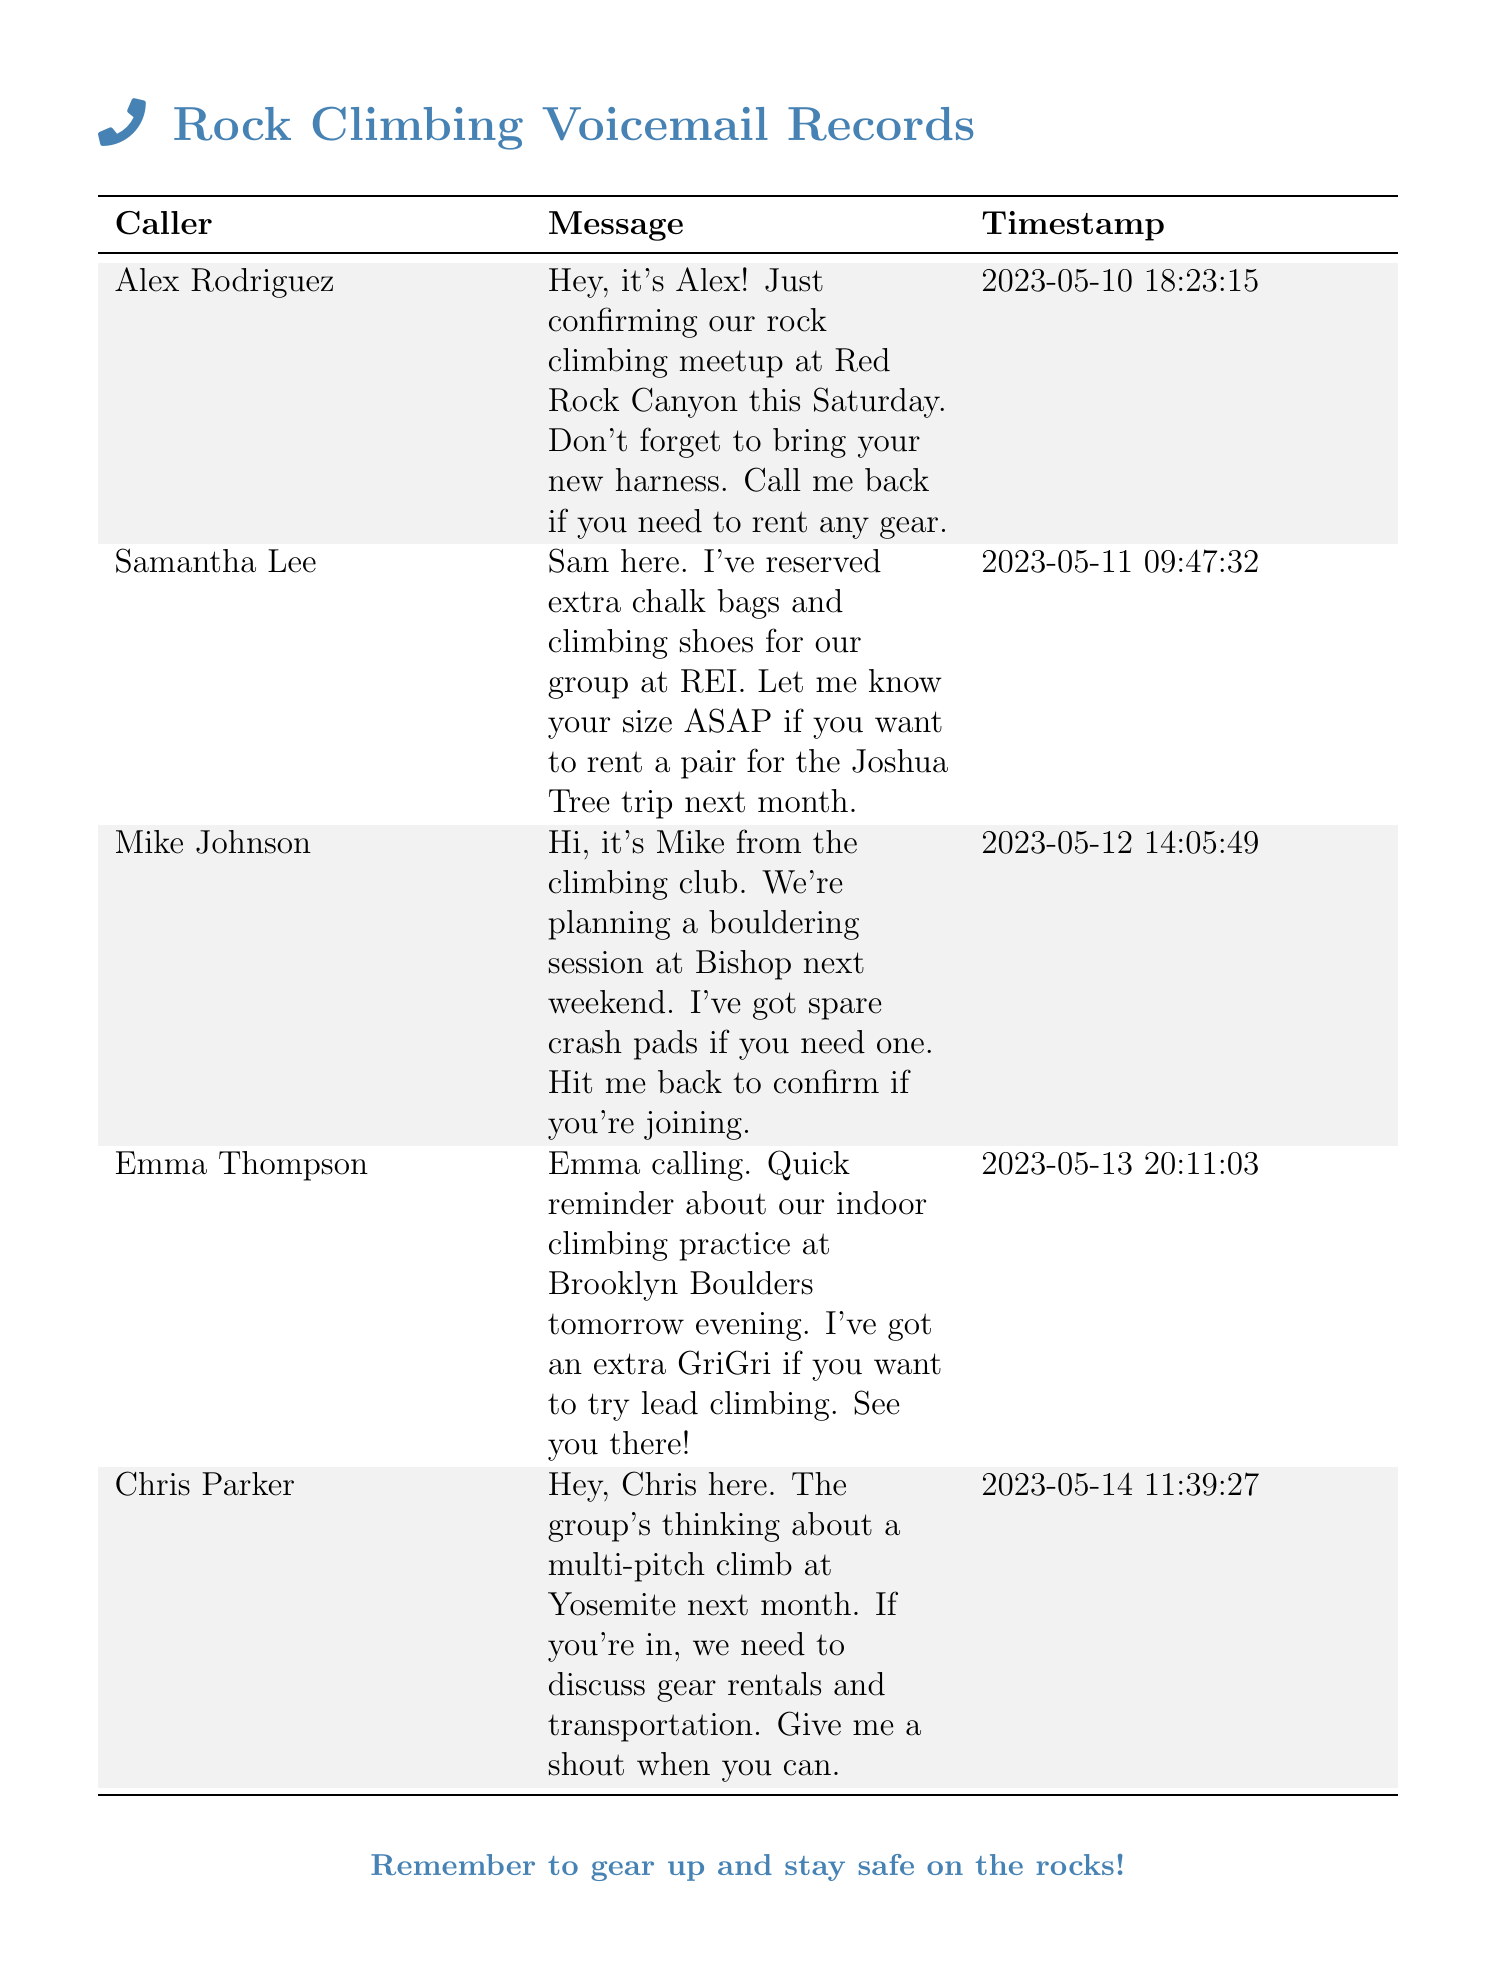What is the date of the rock climbing meetup at Red Rock Canyon? The date mentioned for the meetup at Red Rock Canyon is Saturday, May 13, which can be inferred as the Saturday closest to the voicemail date on May 10.
Answer: May 13 Who reserved extra chalk bags and climbing shoes? The voicemail indicates that Samantha Lee reserved extra chalk bags and climbing shoes for the group.
Answer: Samantha Lee What location is mentioned for the bouldering session? The bouldering session is planned to take place at Bishop, as stated in Mike's voicemail.
Answer: Bishop What equipment does Mike have available for the bouldering session? Mike mentioned having spare crash pads available for the bouldering session.
Answer: Spare crash pads Which feature does Emma offer to the group for lead climbing? Emma offers an extra GriGri, which is a type of belay device used for lead climbing.
Answer: Extra GriGri What is the planned destination for the multi-pitch climb next month? Chris's voicemail indicates that the group's planned destination for the multi-pitch climb is Yosemite.
Answer: Yosemite In which document is the voicemail about the indoor climbing practice located? The voicemail regarding the indoor climbing practice is listed in the Rock Climbing Voicemail Records document.
Answer: Rock Climbing Voicemail Records 